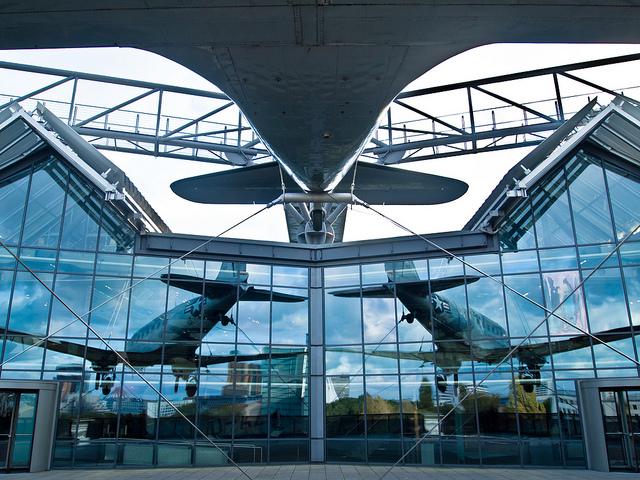How many planes are shown?
Keep it brief. 3. How many windows?
Write a very short answer. Lot. What is the building made of?
Give a very brief answer. Glass. 